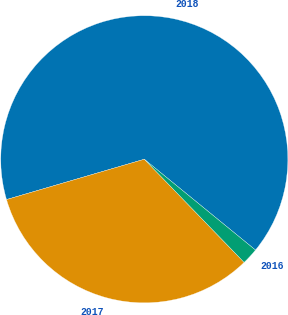Convert chart. <chart><loc_0><loc_0><loc_500><loc_500><pie_chart><fcel>2018<fcel>2017<fcel>2016<nl><fcel>65.43%<fcel>32.71%<fcel>1.86%<nl></chart> 